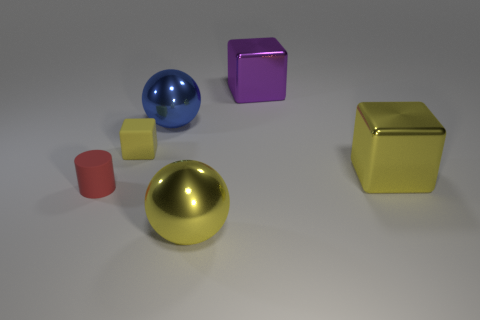There is a yellow thing that is the same shape as the blue thing; what is it made of?
Offer a very short reply. Metal. What size is the yellow ball right of the sphere on the left side of the big metallic ball that is in front of the large blue metallic ball?
Offer a terse response. Large. Does the blue metal ball have the same size as the yellow metal ball?
Give a very brief answer. Yes. The yellow block that is right of the large object that is behind the large blue thing is made of what material?
Keep it short and to the point. Metal. There is a tiny thing to the left of the yellow rubber thing; does it have the same shape as the large yellow thing to the left of the purple cube?
Your answer should be compact. No. Is the number of big blue balls that are to the left of the blue ball the same as the number of blue shiny balls?
Give a very brief answer. No. There is a large metallic cube that is behind the small yellow matte thing; is there a tiny rubber cylinder that is behind it?
Give a very brief answer. No. Are there any other things that have the same color as the small cylinder?
Give a very brief answer. No. Is the material of the yellow cube on the right side of the blue metal thing the same as the large purple cube?
Your response must be concise. Yes. Are there the same number of small things that are left of the yellow metal cube and purple metal things left of the yellow metallic sphere?
Provide a succinct answer. No. 